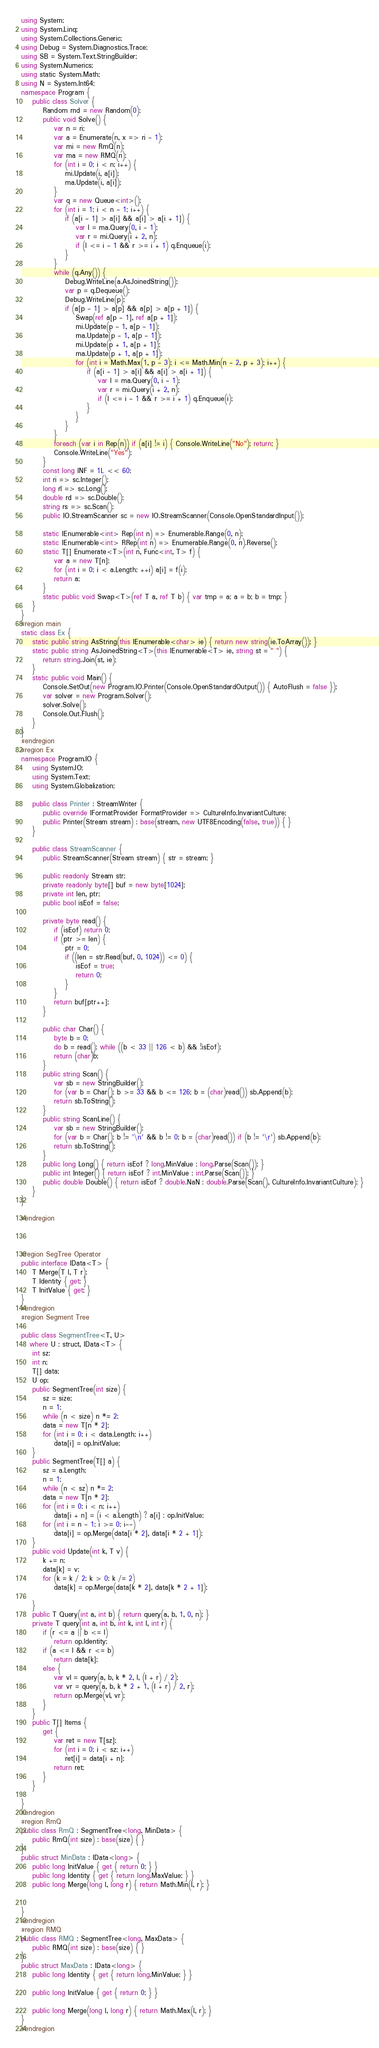Convert code to text. <code><loc_0><loc_0><loc_500><loc_500><_C#_>using System;
using System.Linq;
using System.Collections.Generic;
using Debug = System.Diagnostics.Trace;
using SB = System.Text.StringBuilder;
using System.Numerics;
using static System.Math;
using N = System.Int64;
namespace Program {
    public class Solver {
        Random rnd = new Random(0);
        public void Solve() {
            var n = ri;
            var a = Enumerate(n, x => ri - 1);
            var mi = new RmQ(n);
            var ma = new RMQ(n);
            for (int i = 0; i < n; i++) {
                mi.Update(i, a[i]);
                ma.Update(i, a[i]);
            }
            var q = new Queue<int>();
            for (int i = 1; i < n - 1; i++) {
                if (a[i - 1] > a[i] && a[i] > a[i + 1]) {
                    var l = ma.Query(0, i - 1);
                    var r = mi.Query(i + 2, n);
                    if (l <= i - 1 && r >= i + 1) q.Enqueue(i);
                }
            }
            while (q.Any()) {
                Debug.WriteLine(a.AsJoinedString());
                var p = q.Dequeue();
                Debug.WriteLine(p);
                if (a[p - 1] > a[p] && a[p] > a[p + 1]) {
                    Swap(ref a[p - 1], ref a[p + 1]);
                    mi.Update(p - 1, a[p - 1]);
                    ma.Update(p - 1, a[p - 1]);
                    mi.Update(p + 1, a[p + 1]);
                    ma.Update(p + 1, a[p + 1]);
                    for (int i = Math.Max(1, p - 3); i <= Math.Min(n - 2, p + 3); i++) {
                        if (a[i - 1] > a[i] && a[i] > a[i + 1]) {
                            var l = ma.Query(0, i - 1);
                            var r = mi.Query(i + 2, n);
                            if (l <= i - 1 && r >= i + 1) q.Enqueue(i);
                        }
                    }
                }
            }
            foreach (var i in Rep(n)) if (a[i] != i) { Console.WriteLine("No"); return; }
            Console.WriteLine("Yes");
        }
        const long INF = 1L << 60;
        int ri => sc.Integer();
        long rl => sc.Long();
        double rd => sc.Double();
        string rs => sc.Scan();
        public IO.StreamScanner sc = new IO.StreamScanner(Console.OpenStandardInput());

        static IEnumerable<int> Rep(int n) => Enumerable.Range(0, n);
        static IEnumerable<int> RRep(int n) => Enumerable.Range(0, n).Reverse();
        static T[] Enumerate<T>(int n, Func<int, T> f) {
            var a = new T[n];
            for (int i = 0; i < a.Length; ++i) a[i] = f(i);
            return a;
        }
        static public void Swap<T>(ref T a, ref T b) { var tmp = a; a = b; b = tmp; }
    }
}
#region main
static class Ex {
    static public string AsString(this IEnumerable<char> ie) { return new string(ie.ToArray()); }
    static public string AsJoinedString<T>(this IEnumerable<T> ie, string st = " ") {
        return string.Join(st, ie);
    }
    static public void Main() {
        Console.SetOut(new Program.IO.Printer(Console.OpenStandardOutput()) { AutoFlush = false });
        var solver = new Program.Solver();
        solver.Solve();
        Console.Out.Flush();
    }
}
#endregion
#region Ex
namespace Program.IO {
    using System.IO;
    using System.Text;
    using System.Globalization;

    public class Printer : StreamWriter {
        public override IFormatProvider FormatProvider => CultureInfo.InvariantCulture;
        public Printer(Stream stream) : base(stream, new UTF8Encoding(false, true)) { }
    }

    public class StreamScanner {
        public StreamScanner(Stream stream) { str = stream; }

        public readonly Stream str;
        private readonly byte[] buf = new byte[1024];
        private int len, ptr;
        public bool isEof = false;

        private byte read() {
            if (isEof) return 0;
            if (ptr >= len) {
                ptr = 0;
                if ((len = str.Read(buf, 0, 1024)) <= 0) {
                    isEof = true;
                    return 0;
                }
            }
            return buf[ptr++];
        }

        public char Char() {
            byte b = 0;
            do b = read(); while ((b < 33 || 126 < b) && !isEof);
            return (char)b;
        }
        public string Scan() {
            var sb = new StringBuilder();
            for (var b = Char(); b >= 33 && b <= 126; b = (char)read()) sb.Append(b);
            return sb.ToString();
        }
        public string ScanLine() {
            var sb = new StringBuilder();
            for (var b = Char(); b != '\n' && b != 0; b = (char)read()) if (b != '\r') sb.Append(b);
            return sb.ToString();
        }
        public long Long() { return isEof ? long.MinValue : long.Parse(Scan()); }
        public int Integer() { return isEof ? int.MinValue : int.Parse(Scan()); }
        public double Double() { return isEof ? double.NaN : double.Parse(Scan(), CultureInfo.InvariantCulture); }
    }
}

#endregion



#region SegTree Operator
public interface IData<T> {
    T Merge(T l, T r);
    T Identity { get; }
    T InitValue { get; }
}
#endregion
#region Segment Tree

public class SegmentTree<T, U>
   where U : struct, IData<T> {
    int sz;
    int n;
    T[] data;
    U op;
    public SegmentTree(int size) {
        sz = size;
        n = 1;
        while (n < size) n *= 2;
        data = new T[n * 2];
        for (int i = 0; i < data.Length; i++)
            data[i] = op.InitValue;
    }
    public SegmentTree(T[] a) {
        sz = a.Length;
        n = 1;
        while (n < sz) n *= 2;
        data = new T[n * 2];
        for (int i = 0; i < n; i++)
            data[i + n] = (i < a.Length) ? a[i] : op.InitValue;
        for (int i = n - 1; i >= 0; i--)
            data[i] = op.Merge(data[i * 2], data[i * 2 + 1]);
    }
    public void Update(int k, T v) {
        k += n;
        data[k] = v;
        for (k = k / 2; k > 0; k /= 2)
            data[k] = op.Merge(data[k * 2], data[k * 2 + 1]);

    }
    public T Query(int a, int b) { return query(a, b, 1, 0, n); }
    private T query(int a, int b, int k, int l, int r) {
        if (r <= a || b <= l)
            return op.Identity;
        if (a <= l && r <= b)
            return data[k];
        else {
            var vl = query(a, b, k * 2, l, (l + r) / 2);
            var vr = query(a, b, k * 2 + 1, (l + r) / 2, r);
            return op.Merge(vl, vr);
        }
    }
    public T[] Items {
        get {
            var ret = new T[sz];
            for (int i = 0; i < sz; i++)
                ret[i] = data[i + n];
            return ret;
        }
    }

}
#endregion
#region RmQ
public class RmQ : SegmentTree<long, MinData> {
    public RmQ(int size) : base(size) { }
}
public struct MinData : IData<long> {
    public long InitValue { get { return 0; } }
    public long Identity { get { return long.MaxValue; } }
    public long Merge(long l, long r) { return Math.Min(l, r); }


}
#endregion
#region RMQ
public class RMQ : SegmentTree<long, MaxData> {
    public RMQ(int size) : base(size) { }
}
public struct MaxData : IData<long> {
    public long Identity { get { return long.MinValue; } }

    public long InitValue { get { return 0; } }

    public long Merge(long l, long r) { return Math.Max(l, r); }
}
#endregion
</code> 